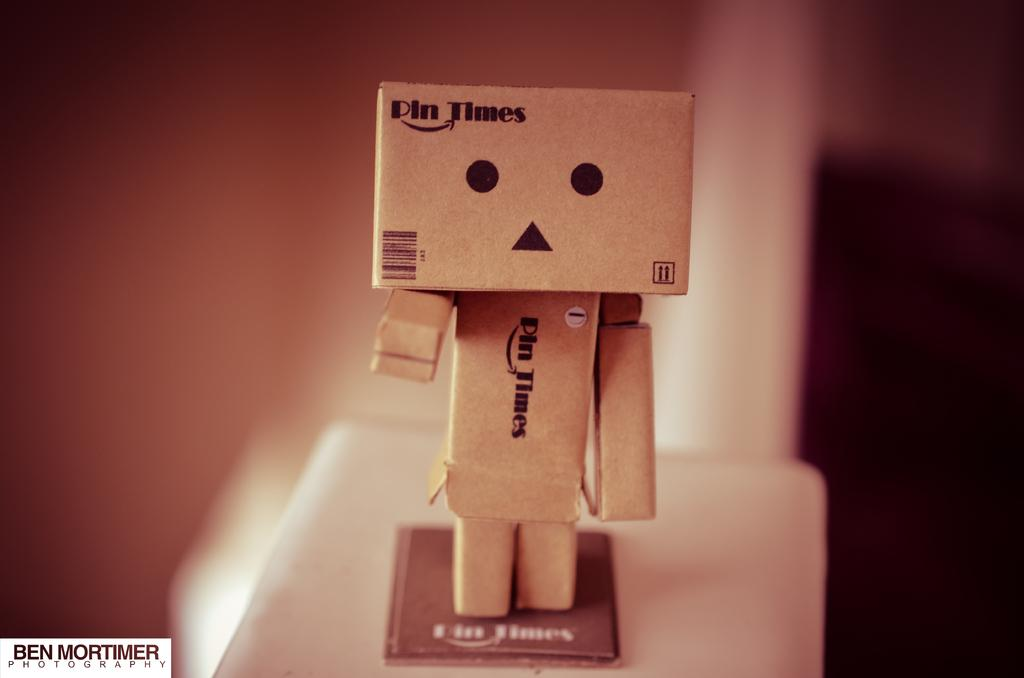What is the main subject of the image? The main subject of the image is a baby toy made with papers. Where is the baby toy located in the image? The baby toy is placed on a surface in the image. What can be seen on the baby toy? There is text visible on the baby toy. How many servants are attending to the baby toy in the image? There are no servants present in the image; it only features a baby toy made with papers. What type of land can be seen in the image? There is no land visible in the image; it only features a baby toy made with papers placed on a surface. 